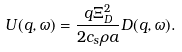<formula> <loc_0><loc_0><loc_500><loc_500>U ( q , \omega ) = \frac { q \Xi _ { D } ^ { 2 } } { 2 c _ { s } \rho a } D ( q , \omega ) .</formula> 